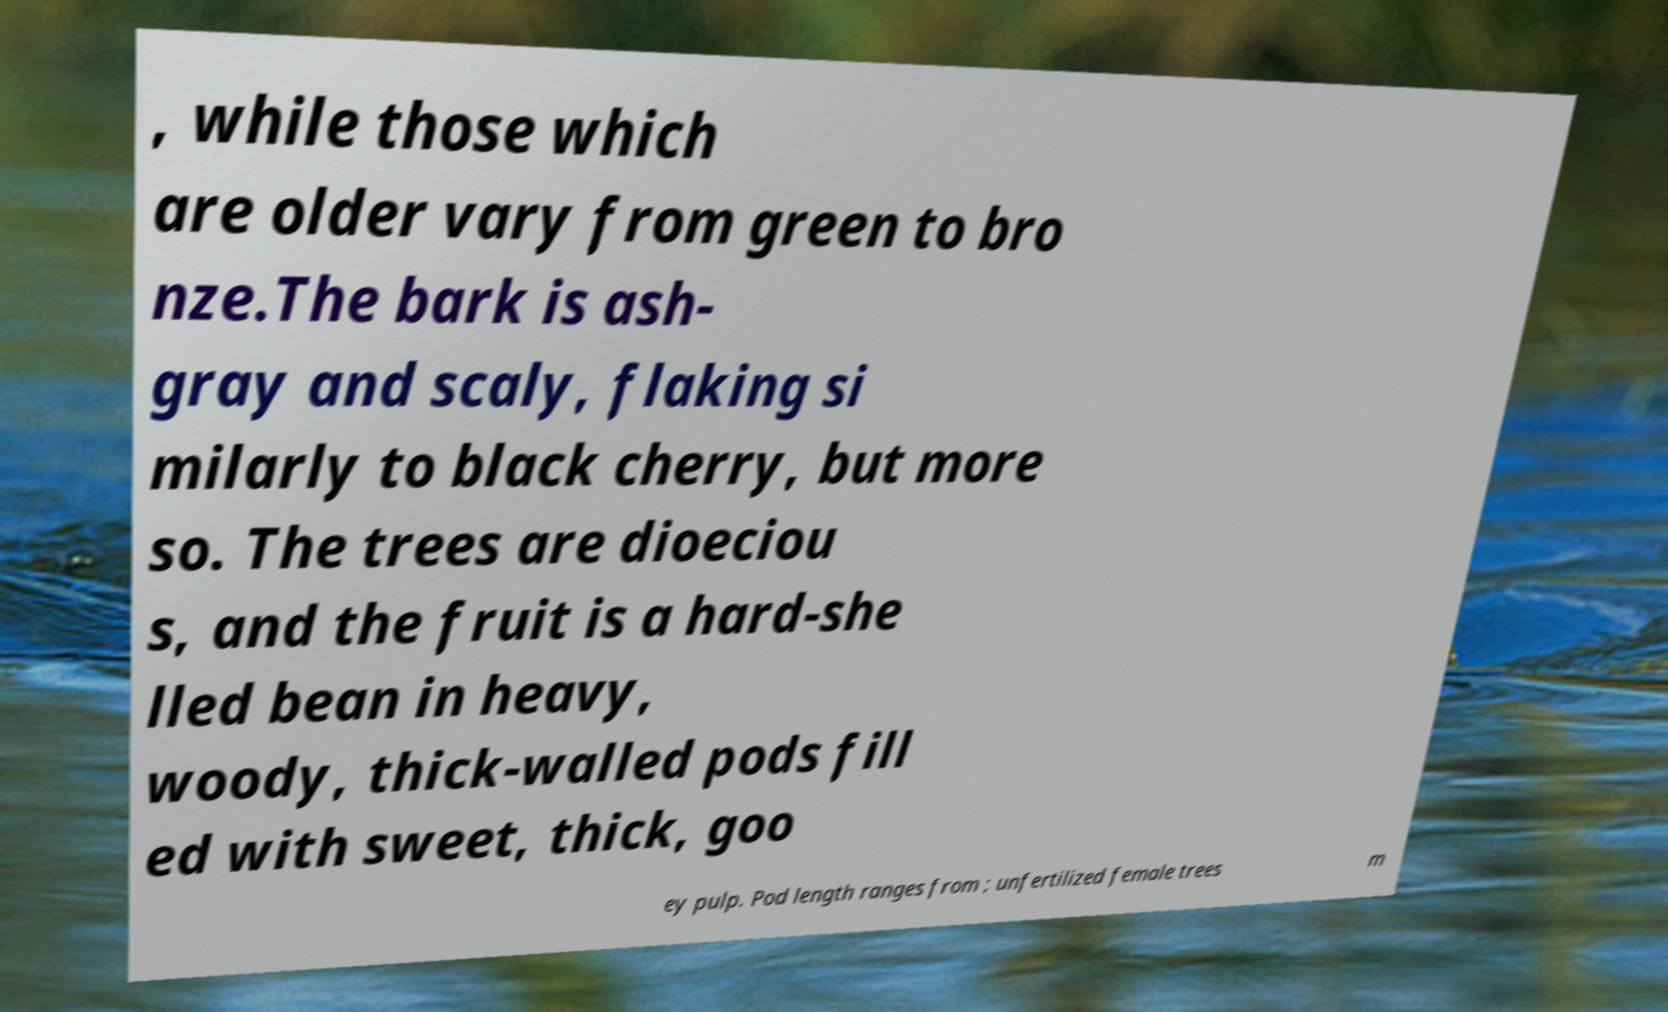Can you accurately transcribe the text from the provided image for me? , while those which are older vary from green to bro nze.The bark is ash- gray and scaly, flaking si milarly to black cherry, but more so. The trees are dioeciou s, and the fruit is a hard-she lled bean in heavy, woody, thick-walled pods fill ed with sweet, thick, goo ey pulp. Pod length ranges from ; unfertilized female trees m 